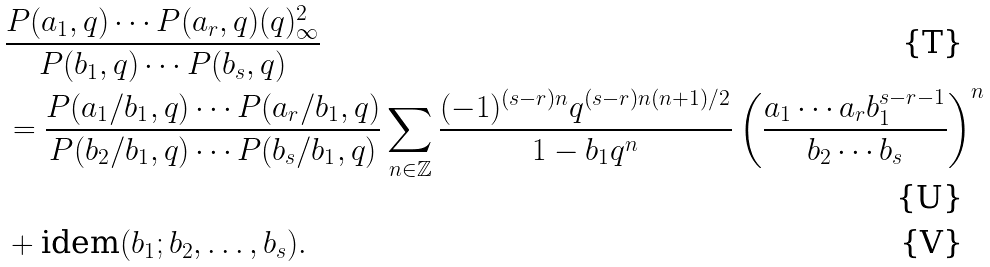Convert formula to latex. <formula><loc_0><loc_0><loc_500><loc_500>& \frac { P ( a _ { 1 } , q ) \cdots P ( a _ { r } , q ) ( q ) _ { \infty } ^ { 2 } } { P ( b _ { 1 } , q ) \cdots P ( b _ { s } , q ) } \\ & = \frac { P ( a _ { 1 } / b _ { 1 } , q ) \cdots P ( a _ { r } / b _ { 1 } , q ) } { P ( b _ { 2 } / b _ { 1 } , q ) \cdots P ( b _ { s } / b _ { 1 } , q ) } \sum _ { n \in \mathbb { Z } } \frac { ( - 1 ) ^ { ( s - r ) n } q ^ { ( s - r ) n ( n + 1 ) / 2 } } { 1 - b _ { 1 } q ^ { n } } \left ( \frac { a _ { 1 } \cdots a _ { r } b _ { 1 } ^ { s - r - 1 } } { b _ { 2 } \cdots b _ { s } } \right ) ^ { n } \\ & + \text {idem} ( b _ { 1 } ; b _ { 2 } , \dots , b _ { s } ) .</formula> 